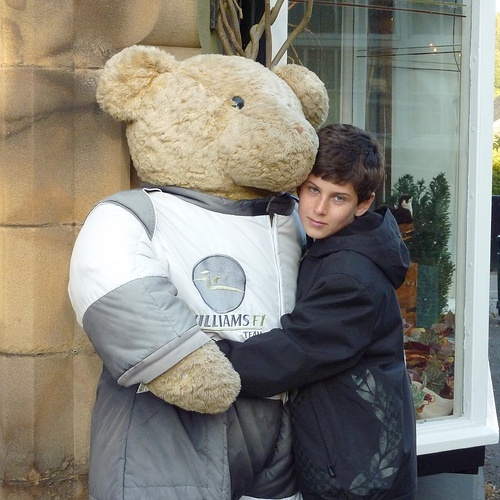Describe the objects in this image and their specific colors. I can see teddy bear in tan, white, darkgray, and gray tones and people in tan, black, gray, and darkblue tones in this image. 